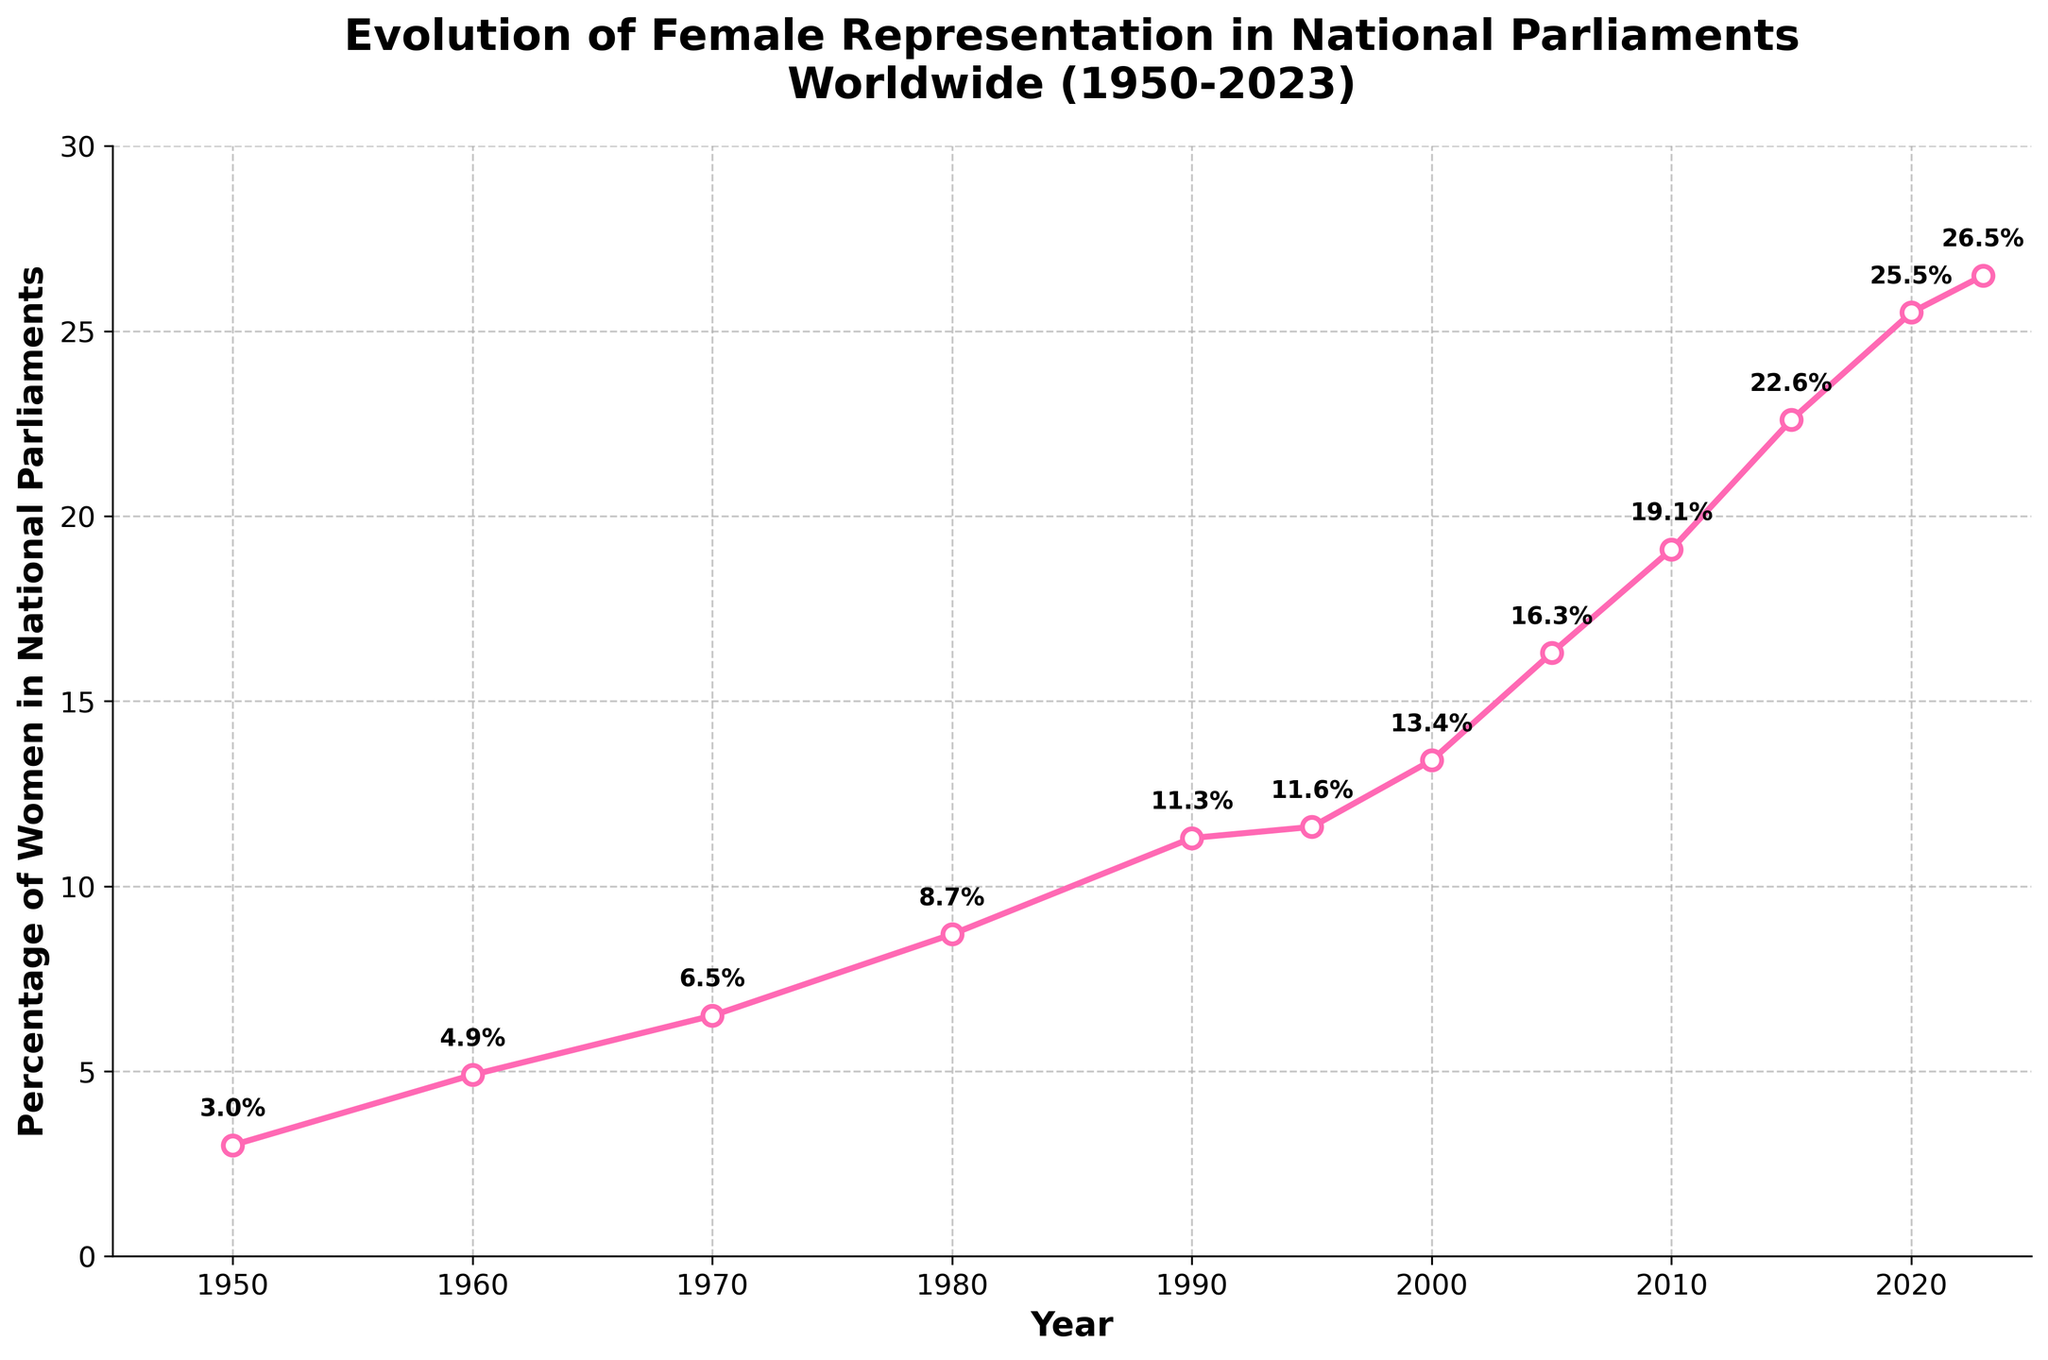How much did the percentage of female representation in national parliaments worldwide increase from 1950 to 2023? The percentage in 1950 was 3.0% and in 2023 it is 26.5%. To find the increase, subtract the 1950 percentage from the 2023 percentage: 26.5% - 3.0% = 23.5%
Answer: 23.5% Which decade saw the highest increase in female representation in national parliaments? Compare the increase for each decade: 1950-1960: 4.9% - 3.0% = 1.9%, 1960-1970: 6.5% - 4.9% = 1.6%, 1970-1980: 8.7% - 6.5% = 2.2%, 1980-1990: 11.3% - 8.7% = 2.6%, 1990-2000: 13.4% - 11.3% = 2.1%, 2000-2010: 19.1% - 13.4% = 5.7%, 2010-2020: 25.5% - 19.1% = 6.4%. The most significant increase occurred between 2010-2020 with 6.4%.
Answer: 2010-2020 What is the average percentage of female representation for the entire period shown in the plot? Sum the percentages and divide by the number of data points: (3.0 + 4.9 + 6.5 + 8.7 + 11.3 + 11.6 + 13.4 + 16.3 + 19.1 + 22.6 + 25.5 + 26.5) / 12 = 12.95%
Answer: 12.95% What was the percentage increase in female representation between the years 2000 and 2015? The percentage in 2000 was 13.4% and in 2015 it was 22.6%. Subtract the percentage in 2000 from that in 2015: 22.6% - 13.4% = 9.2%
Answer: 9.2% Between 1980 and 2000, in which year did the percentage grow more distinctly? Compare the increase between the years: 1980-1990: 11.3% - 8.7% = 2.6%, 1990-1995: 11.6% - 11.3% = 0.3%, 1995-2000: 13.4% - 11.6% = 1.8%. The most significant growth occurred between 1980 and 1990 with an increase of 2.6%.
Answer: 1980-1990 